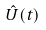Convert formula to latex. <formula><loc_0><loc_0><loc_500><loc_500>\hat { U } ( t )</formula> 